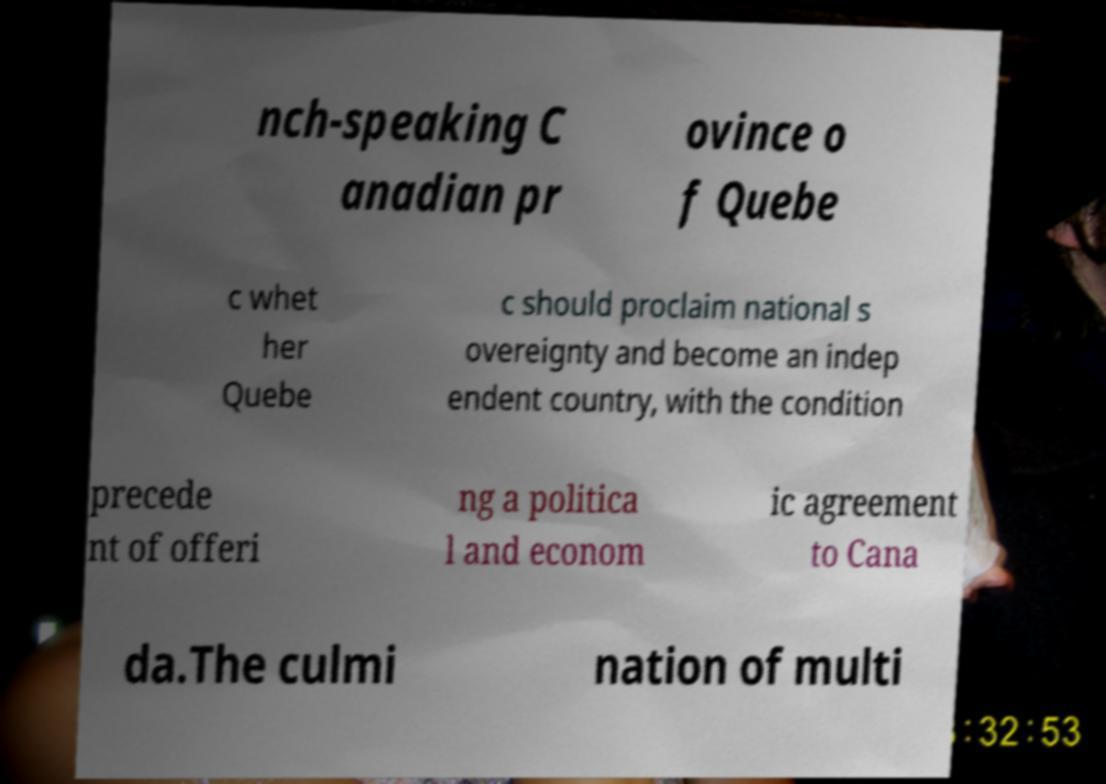I need the written content from this picture converted into text. Can you do that? nch-speaking C anadian pr ovince o f Quebe c whet her Quebe c should proclaim national s overeignty and become an indep endent country, with the condition precede nt of offeri ng a politica l and econom ic agreement to Cana da.The culmi nation of multi 